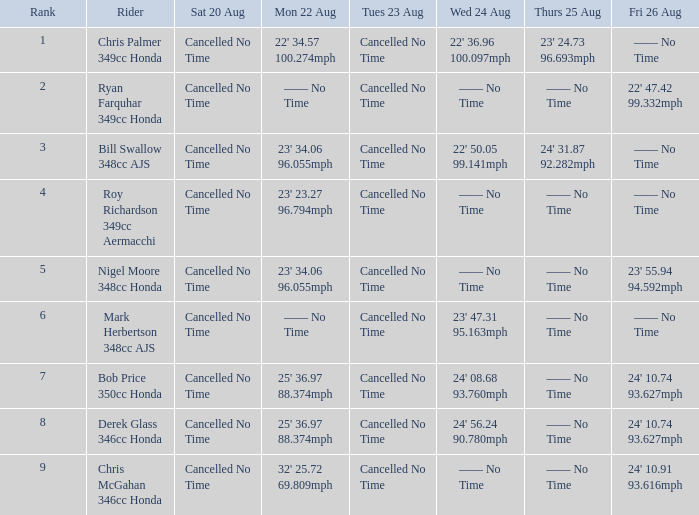05 9 23' 34.06 96.055mph. Would you be able to parse every entry in this table? {'header': ['Rank', 'Rider', 'Sat 20 Aug', 'Mon 22 Aug', 'Tues 23 Aug', 'Wed 24 Aug', 'Thurs 25 Aug', 'Fri 26 Aug'], 'rows': [['1', 'Chris Palmer 349cc Honda', 'Cancelled No Time', "22' 34.57 100.274mph", 'Cancelled No Time', "22' 36.96 100.097mph", "23' 24.73 96.693mph", '—— No Time'], ['2', 'Ryan Farquhar 349cc Honda', 'Cancelled No Time', '—— No Time', 'Cancelled No Time', '—— No Time', '—— No Time', "22' 47.42 99.332mph"], ['3', 'Bill Swallow 348cc AJS', 'Cancelled No Time', "23' 34.06 96.055mph", 'Cancelled No Time', "22' 50.05 99.141mph", "24' 31.87 92.282mph", '—— No Time'], ['4', 'Roy Richardson 349cc Aermacchi', 'Cancelled No Time', "23' 23.27 96.794mph", 'Cancelled No Time', '—— No Time', '—— No Time', '—— No Time'], ['5', 'Nigel Moore 348cc Honda', 'Cancelled No Time', "23' 34.06 96.055mph", 'Cancelled No Time', '—— No Time', '—— No Time', "23' 55.94 94.592mph"], ['6', 'Mark Herbertson 348cc AJS', 'Cancelled No Time', '—— No Time', 'Cancelled No Time', "23' 47.31 95.163mph", '—— No Time', '—— No Time'], ['7', 'Bob Price 350cc Honda', 'Cancelled No Time', "25' 36.97 88.374mph", 'Cancelled No Time', "24' 08.68 93.760mph", '—— No Time', "24' 10.74 93.627mph"], ['8', 'Derek Glass 346cc Honda', 'Cancelled No Time', "25' 36.97 88.374mph", 'Cancelled No Time', "24' 56.24 90.780mph", '—— No Time', "24' 10.74 93.627mph"], ['9', 'Chris McGahan 346cc Honda', 'Cancelled No Time', "32' 25.72 69.809mph", 'Cancelled No Time', '—— No Time', '—— No Time', "24' 10.91 93.616mph"]]} 